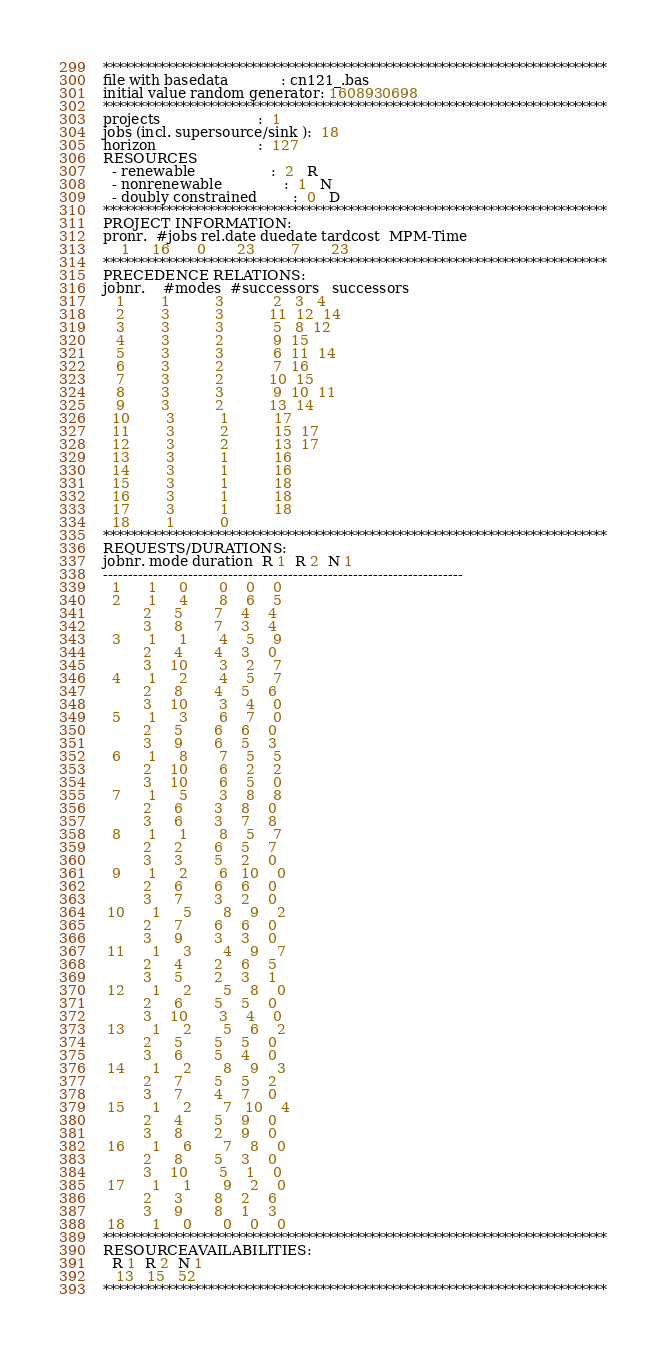<code> <loc_0><loc_0><loc_500><loc_500><_ObjectiveC_>************************************************************************
file with basedata            : cn121_.bas
initial value random generator: 1608930698
************************************************************************
projects                      :  1
jobs (incl. supersource/sink ):  18
horizon                       :  127
RESOURCES
  - renewable                 :  2   R
  - nonrenewable              :  1   N
  - doubly constrained        :  0   D
************************************************************************
PROJECT INFORMATION:
pronr.  #jobs rel.date duedate tardcost  MPM-Time
    1     16      0       23        7       23
************************************************************************
PRECEDENCE RELATIONS:
jobnr.    #modes  #successors   successors
   1        1          3           2   3   4
   2        3          3          11  12  14
   3        3          3           5   8  12
   4        3          2           9  15
   5        3          3           6  11  14
   6        3          2           7  16
   7        3          2          10  15
   8        3          3           9  10  11
   9        3          2          13  14
  10        3          1          17
  11        3          2          15  17
  12        3          2          13  17
  13        3          1          16
  14        3          1          16
  15        3          1          18
  16        3          1          18
  17        3          1          18
  18        1          0        
************************************************************************
REQUESTS/DURATIONS:
jobnr. mode duration  R 1  R 2  N 1
------------------------------------------------------------------------
  1      1     0       0    0    0
  2      1     4       8    6    5
         2     5       7    4    4
         3     8       7    3    4
  3      1     1       4    5    9
         2     4       4    3    0
         3    10       3    2    7
  4      1     2       4    5    7
         2     8       4    5    6
         3    10       3    4    0
  5      1     3       6    7    0
         2     5       6    6    0
         3     9       6    5    3
  6      1     8       7    5    5
         2    10       6    2    2
         3    10       6    5    0
  7      1     5       3    8    8
         2     6       3    8    0
         3     6       3    7    8
  8      1     1       8    5    7
         2     2       6    5    7
         3     3       5    2    0
  9      1     2       6   10    0
         2     6       6    6    0
         3     7       3    2    0
 10      1     5       8    9    2
         2     7       6    6    0
         3     9       3    3    0
 11      1     3       4    9    7
         2     4       2    6    5
         3     5       2    3    1
 12      1     2       5    8    0
         2     6       5    5    0
         3    10       3    4    0
 13      1     2       5    6    2
         2     5       5    5    0
         3     6       5    4    0
 14      1     2       8    9    3
         2     7       5    5    2
         3     7       4    7    0
 15      1     2       7   10    4
         2     4       5    9    0
         3     8       2    9    0
 16      1     6       7    8    0
         2     8       5    3    0
         3    10       5    1    0
 17      1     1       9    2    0
         2     3       8    2    6
         3     9       8    1    3
 18      1     0       0    0    0
************************************************************************
RESOURCEAVAILABILITIES:
  R 1  R 2  N 1
   13   15   52
************************************************************************
</code> 